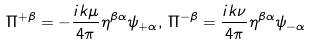Convert formula to latex. <formula><loc_0><loc_0><loc_500><loc_500>\Pi ^ { + \beta } = - \frac { i k \mu } { 4 \pi } \eta ^ { \beta \alpha } \psi _ { + \alpha } , \, \Pi ^ { - \beta } = \frac { i k \nu } { 4 \pi } \eta ^ { \beta \alpha } \psi _ { - \alpha }</formula> 